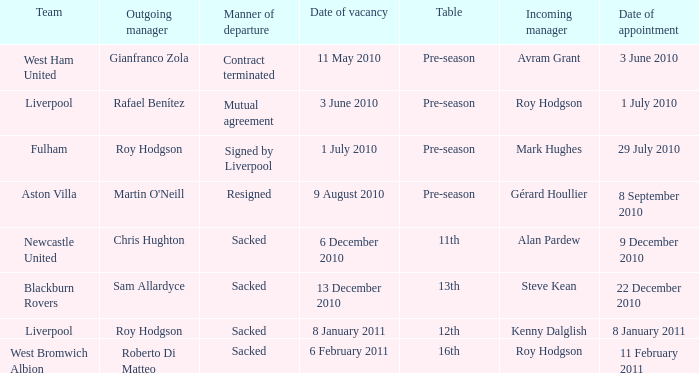How many subsequent managers took over after roy hodgson left the role for the fulham team? 1.0. 